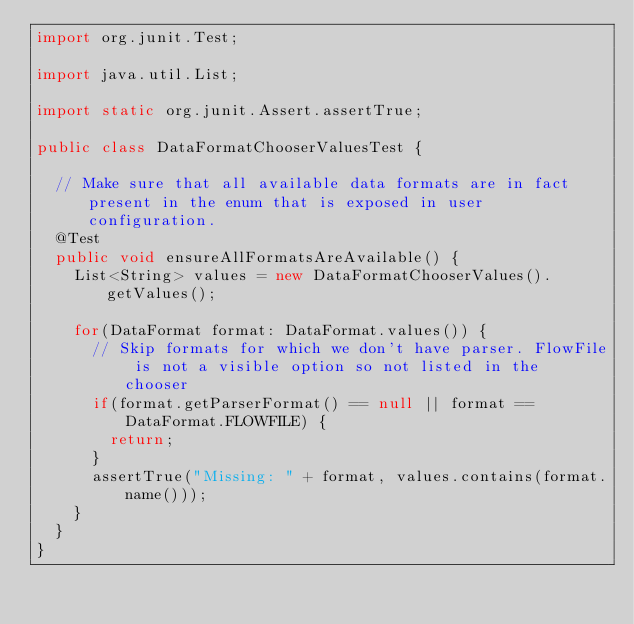<code> <loc_0><loc_0><loc_500><loc_500><_Java_>import org.junit.Test;

import java.util.List;

import static org.junit.Assert.assertTrue;

public class DataFormatChooserValuesTest {

  // Make sure that all available data formats are in fact present in the enum that is exposed in user configuration.
  @Test
  public void ensureAllFormatsAreAvailable() {
    List<String> values = new DataFormatChooserValues().getValues();

    for(DataFormat format: DataFormat.values()) {
      // Skip formats for which we don't have parser. FlowFile is not a visible option so not listed in the chooser
      if(format.getParserFormat() == null || format == DataFormat.FLOWFILE) {
        return;
      }
      assertTrue("Missing: " + format, values.contains(format.name()));
    }
  }
}
</code> 